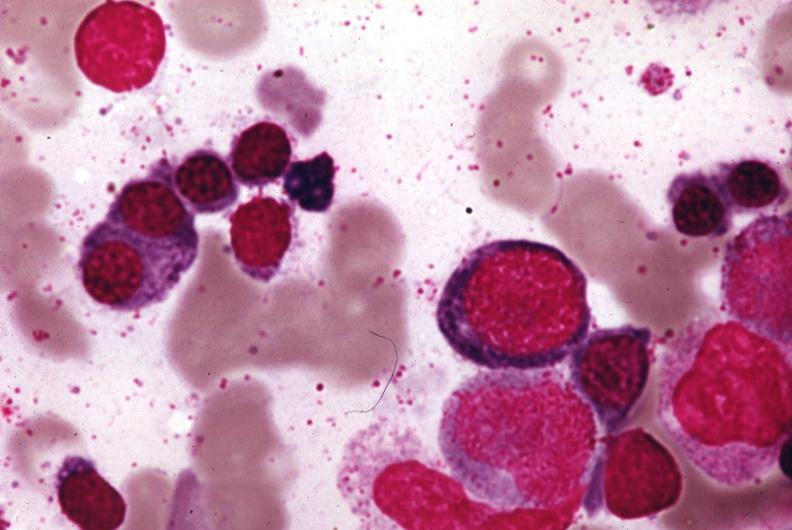s megaloblasts pernicious anemia present?
Answer the question using a single word or phrase. Yes 